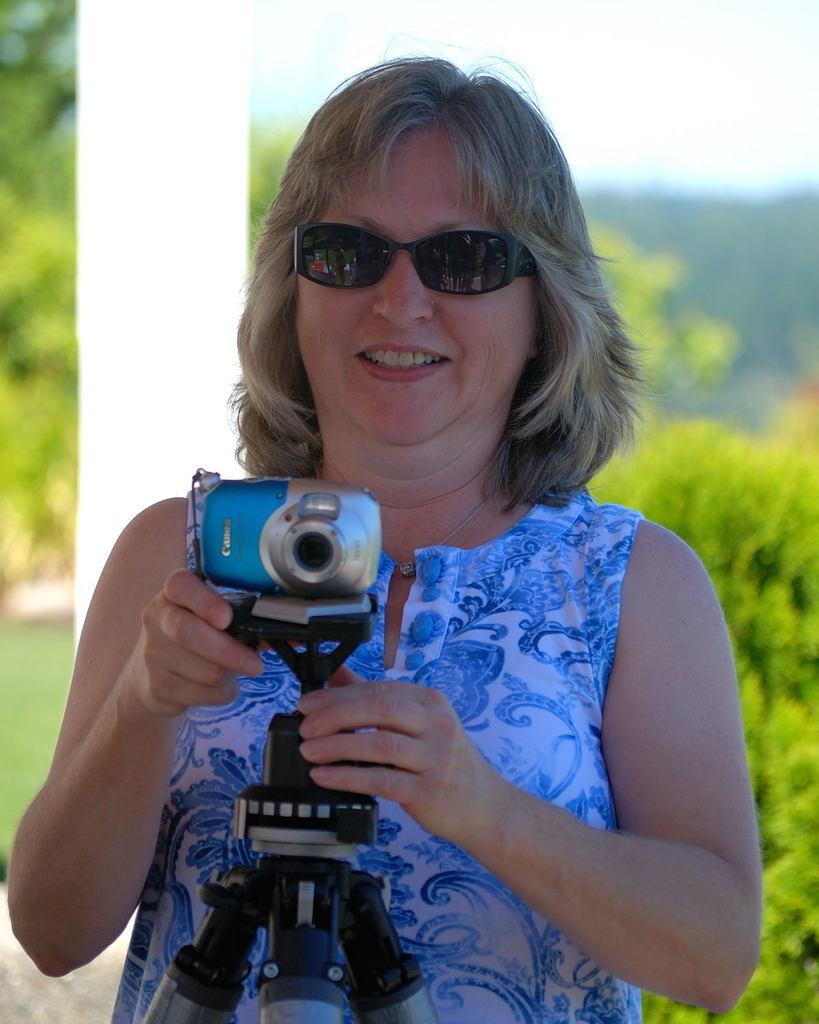Who is the main subject in the image? There is a woman in the image. What is the woman doing in the image? The woman is standing and holding a camera in her hand. What can be seen in the background of the image? There are trees and the sky visible in the background of the image. What type of pollution can be seen in the image? There is no pollution visible in the image; it features a woman standing with a camera and a background of trees and the sky. 